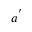<formula> <loc_0><loc_0><loc_500><loc_500>a ^ { ^ { \prime } }</formula> 